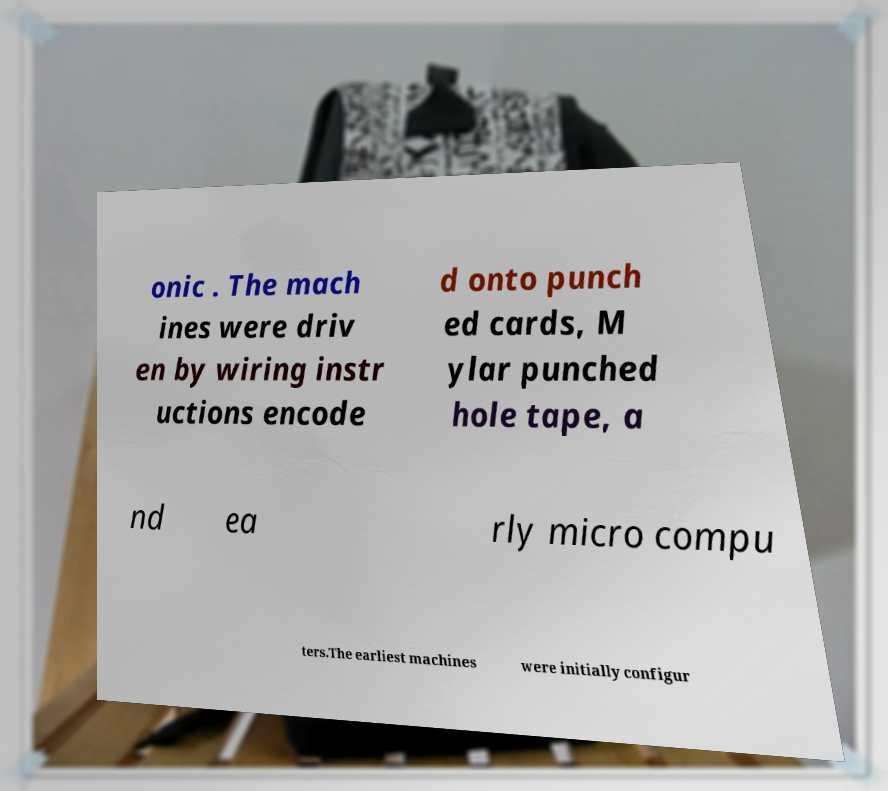I need the written content from this picture converted into text. Can you do that? onic . The mach ines were driv en by wiring instr uctions encode d onto punch ed cards, M ylar punched hole tape, a nd ea rly micro compu ters.The earliest machines were initially configur 